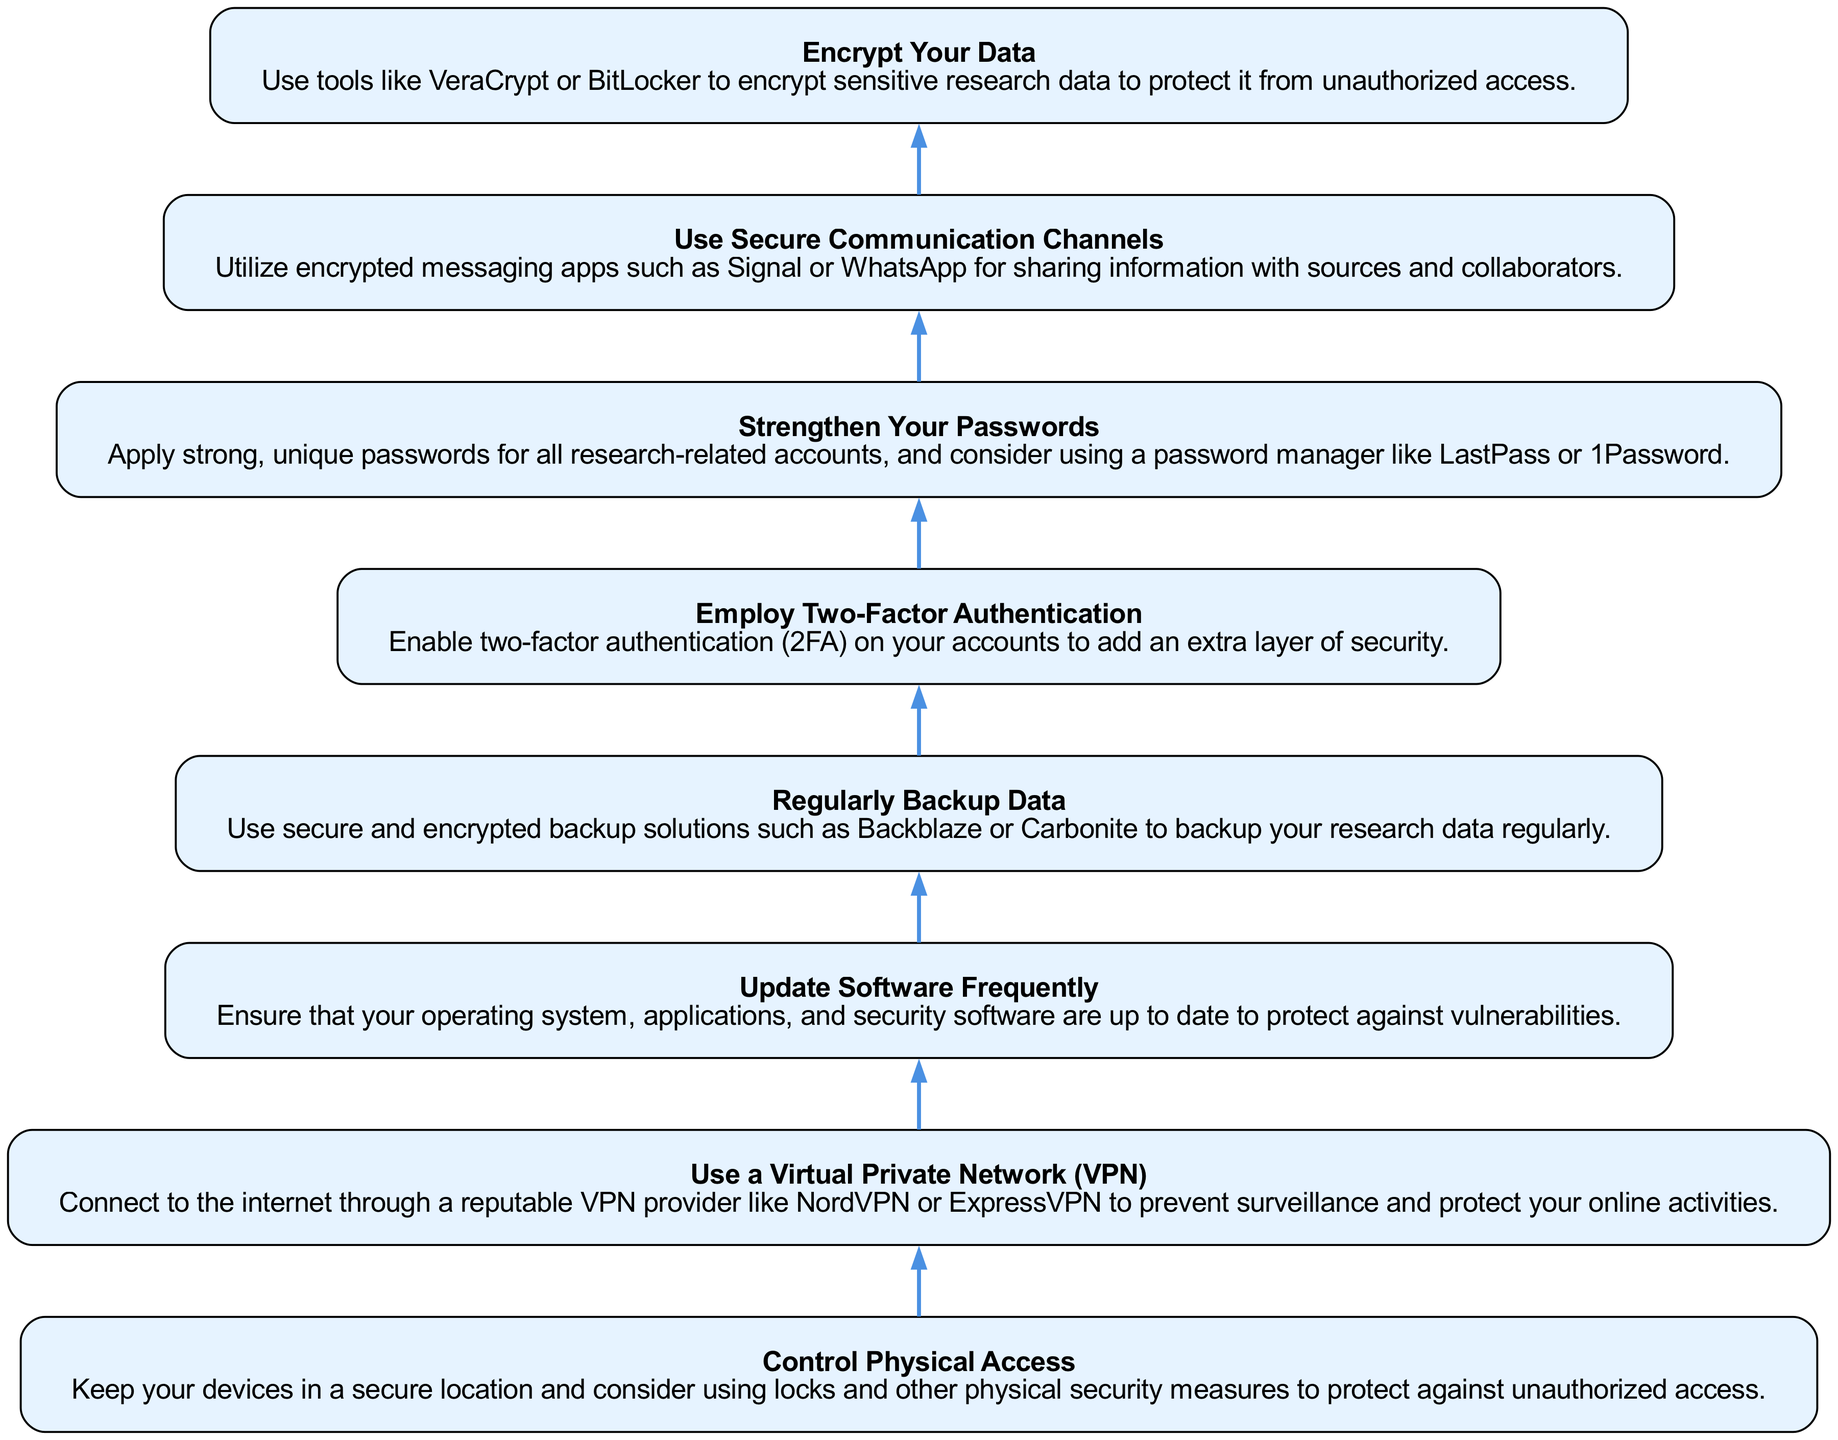What is the first step in the diagram? The diagram flows from bottom to top, and the last step added at the bottom is "Control Physical Access," which is the first visible step when reading it upwards.
Answer: Control Physical Access How many nodes are present in the diagram? Each unique instruction or step in the diagram represents a node, and there are a total of 8 different steps listed.
Answer: 8 What node comes after "Use a Virtual Private Network (VPN)"? In the flow of the diagram, the next step above "Use a Virtual Private Network (VPN)" is "Update Software Frequently," as the process moves upwards sequentially.
Answer: Update Software Frequently Which step involves sharing information with sources? The relevant step for sharing information securely with sources is "Use Secure Communication Channels," indicating that specific action to be taken for that purpose.
Answer: Use Secure Communication Channels What is the relationship between "Employ Two-Factor Authentication" and "Strengthen Your Passwords"? The relationship is sequential in the flow; "Employ Two-Factor Authentication" comes directly above "Strengthen Your Passwords," suggesting that both should be implemented as steps to enhance data security.
Answer: Sequential relationship What type of tools should you use for encrypting data? The step titled "Encrypt Your Data" specifically recommends using tools like VeraCrypt or BitLocker for encryption purposes.
Answer: VeraCrypt or BitLocker What is the last step above "Regularly Backup Data"? The step directly above "Regularly Backup Data" is "Employ Two-Factor Authentication," following the flow from the bottom up.
Answer: Employ Two-Factor Authentication Which step emphasizes using strong passwords? The relevant step dedicated to password security is "Strengthen Your Passwords," focusing on the importance of unique and strong passwords for all accounts.
Answer: Strengthen Your Passwords 